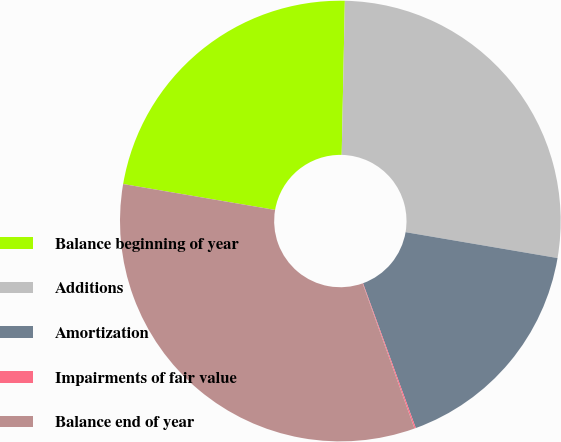<chart> <loc_0><loc_0><loc_500><loc_500><pie_chart><fcel>Balance beginning of year<fcel>Additions<fcel>Amortization<fcel>Impairments of fair value<fcel>Balance end of year<nl><fcel>22.64%<fcel>27.36%<fcel>16.75%<fcel>0.1%<fcel>33.15%<nl></chart> 